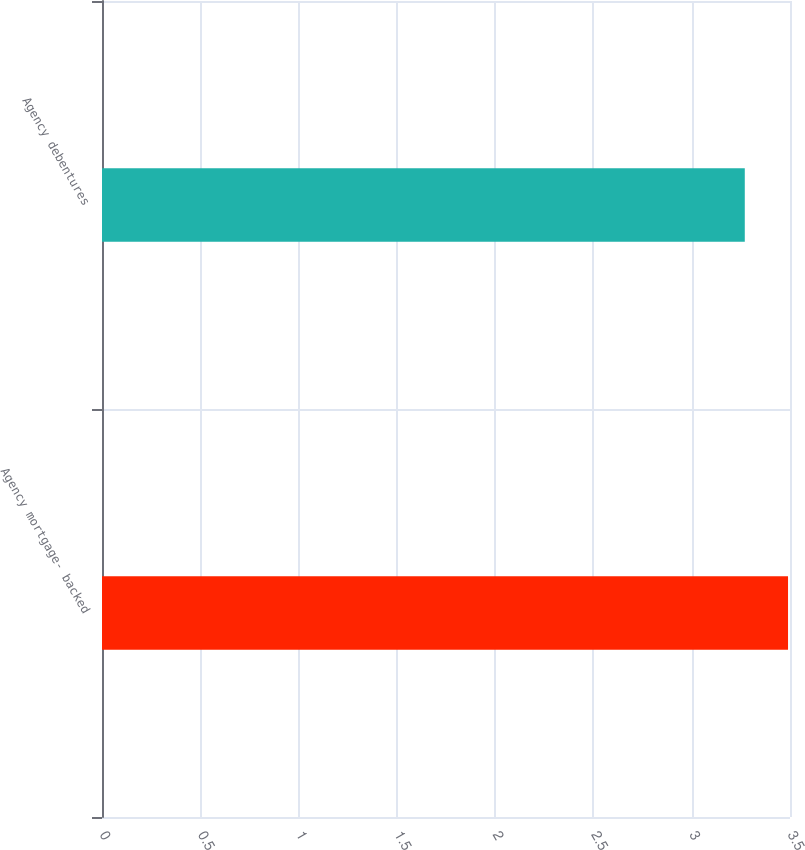Convert chart to OTSL. <chart><loc_0><loc_0><loc_500><loc_500><bar_chart><fcel>Agency mortgage- backed<fcel>Agency debentures<nl><fcel>3.49<fcel>3.27<nl></chart> 